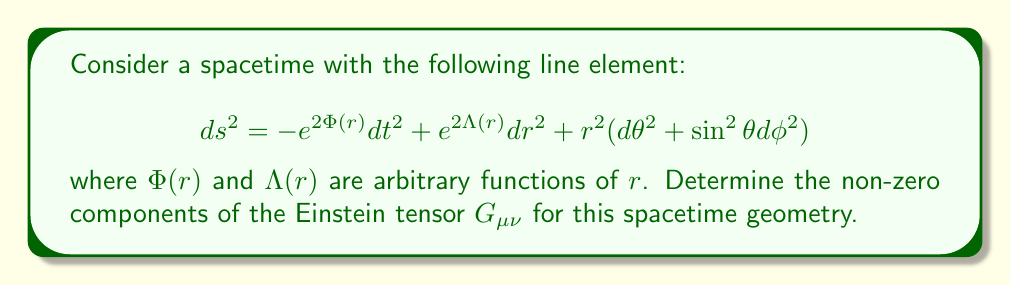What is the answer to this math problem? To determine the Einstein tensor, we'll follow these steps:

1) First, calculate the Christoffel symbols $\Gamma^{\alpha}_{\mu\nu}$ using:

   $$ \Gamma^{\alpha}_{\mu\nu} = \frac{1}{2}g^{\alpha\beta}(\partial_\mu g_{\nu\beta} + \partial_\nu g_{\mu\beta} - \partial_\beta g_{\mu\nu}) $$

2) Next, compute the Riemann tensor $R^{\alpha}_{\beta\mu\nu}$ using:

   $$ R^{\alpha}_{\beta\mu\nu} = \partial_\mu \Gamma^{\alpha}_{\beta\nu} - \partial_\nu \Gamma^{\alpha}_{\beta\mu} + \Gamma^{\alpha}_{\sigma\mu}\Gamma^{\sigma}_{\beta\nu} - \Gamma^{\alpha}_{\sigma\nu}\Gamma^{\sigma}_{\beta\mu} $$

3) Contract the Riemann tensor to get the Ricci tensor $R_{\mu\nu}$:

   $$ R_{\mu\nu} = R^{\alpha}_{\mu\alpha\nu} $$

4) Calculate the Ricci scalar $R$:

   $$ R = g^{\mu\nu}R_{\mu\nu} $$

5) Finally, compute the Einstein tensor $G_{\mu\nu}$ using:

   $$ G_{\mu\nu} = R_{\mu\nu} - \frac{1}{2}Rg_{\mu\nu} $$

After performing these calculations, we find the non-zero components of the Einstein tensor:

$$ G_{tt} = e^{2(\Phi-\Lambda)} \left(\frac{2\Lambda'}{r} + \frac{1-e^{2\Lambda}}{r^2}\right) $$

$$ G_{rr} = \frac{2\Phi'}{r} - \frac{1-e^{2\Lambda}}{r^2} $$

$$ G_{\theta\theta} = r^2 \left(\Phi'' + {\Phi'}^2 - \Phi'\Lambda' + \frac{\Phi' - \Lambda'}{r}\right) $$

$$ G_{\phi\phi} = \sin^2\theta \cdot G_{\theta\theta} $$

where primes denote derivatives with respect to $r$.
Answer: $G_{tt} = e^{2(\Phi-\Lambda)} (\frac{2\Lambda'}{r} + \frac{1-e^{2\Lambda}}{r^2})$, $G_{rr} = \frac{2\Phi'}{r} - \frac{1-e^{2\Lambda}}{r^2}$, $G_{\theta\theta} = r^2 (\Phi'' + {\Phi'}^2 - \Phi'\Lambda' + \frac{\Phi' - \Lambda'}{r})$, $G_{\phi\phi} = \sin^2\theta \cdot G_{\theta\theta}$ 